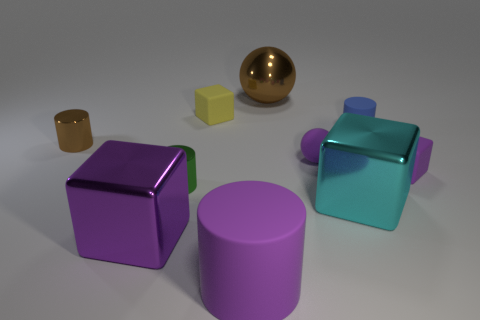Subtract all green cylinders. How many purple blocks are left? 2 Subtract all brown cylinders. How many cylinders are left? 3 Subtract 2 blocks. How many blocks are left? 2 Subtract all purple cylinders. How many cylinders are left? 3 Subtract all blocks. How many objects are left? 6 Subtract all big blocks. Subtract all small metal cylinders. How many objects are left? 6 Add 8 big cyan shiny blocks. How many big cyan shiny blocks are left? 9 Add 1 big purple metallic cubes. How many big purple metallic cubes exist? 2 Subtract 1 purple spheres. How many objects are left? 9 Subtract all green cylinders. Subtract all red balls. How many cylinders are left? 3 